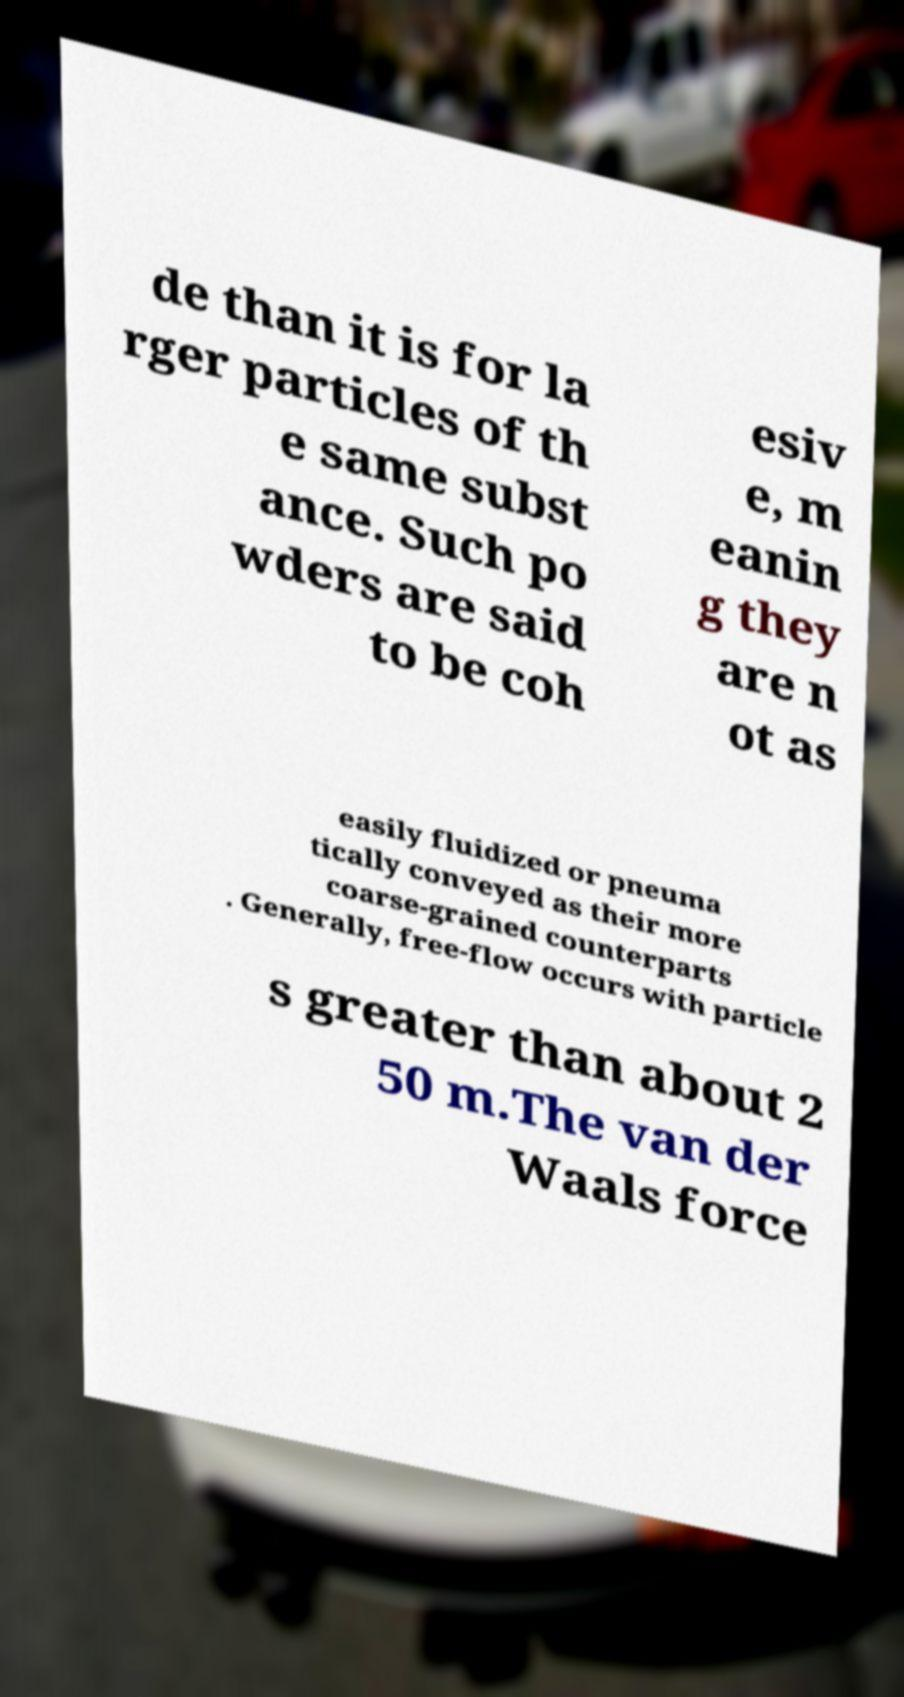Can you read and provide the text displayed in the image?This photo seems to have some interesting text. Can you extract and type it out for me? de than it is for la rger particles of th e same subst ance. Such po wders are said to be coh esiv e, m eanin g they are n ot as easily fluidized or pneuma tically conveyed as their more coarse-grained counterparts . Generally, free-flow occurs with particle s greater than about 2 50 m.The van der Waals force 